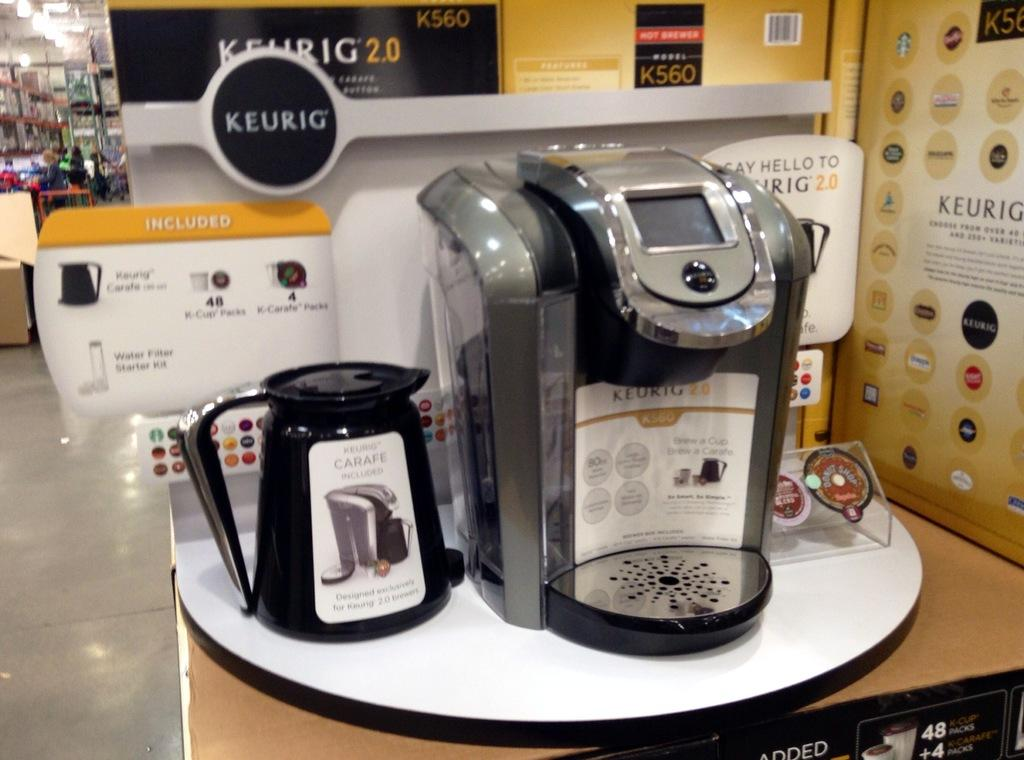<image>
Summarize the visual content of the image. A display of a Keurig coffee machine at a store. 